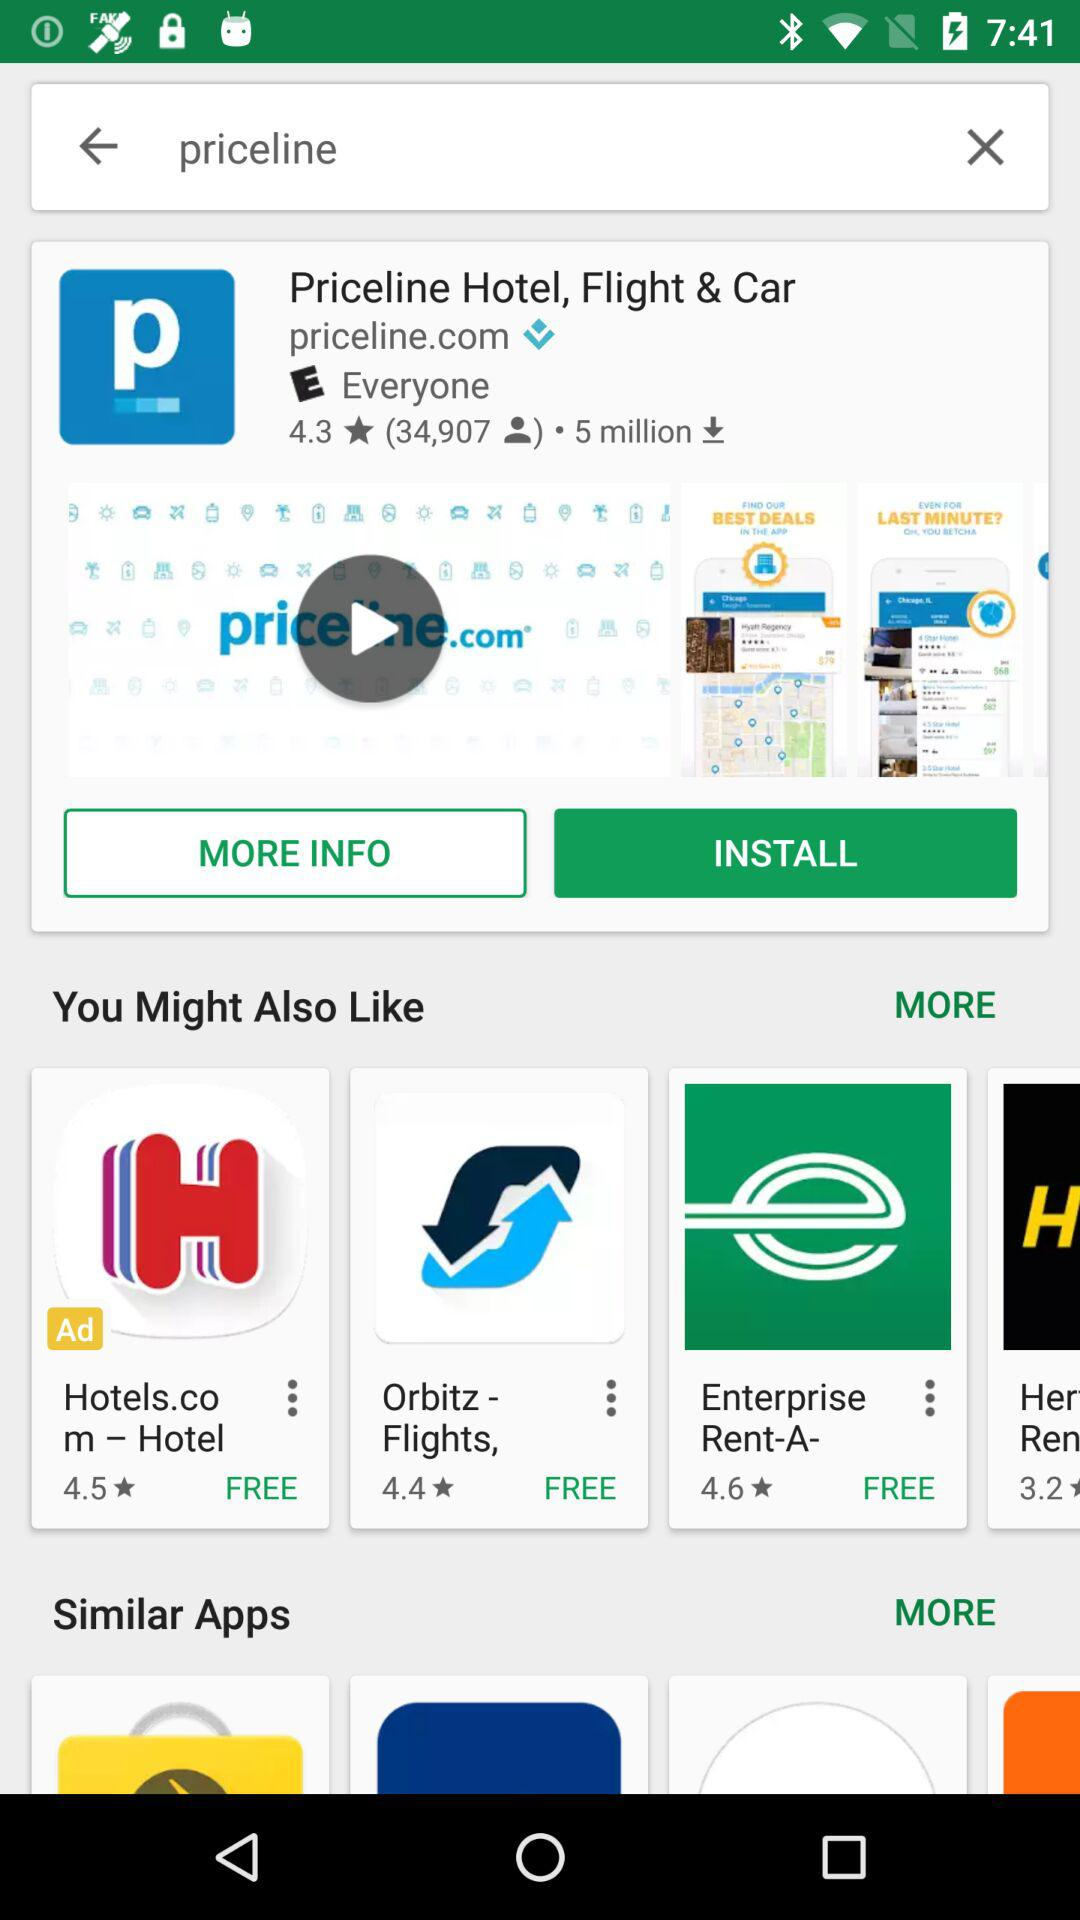What is the rating of the "Priceline Hotel, Flight & Car"? The rating is 4.3 stars. 